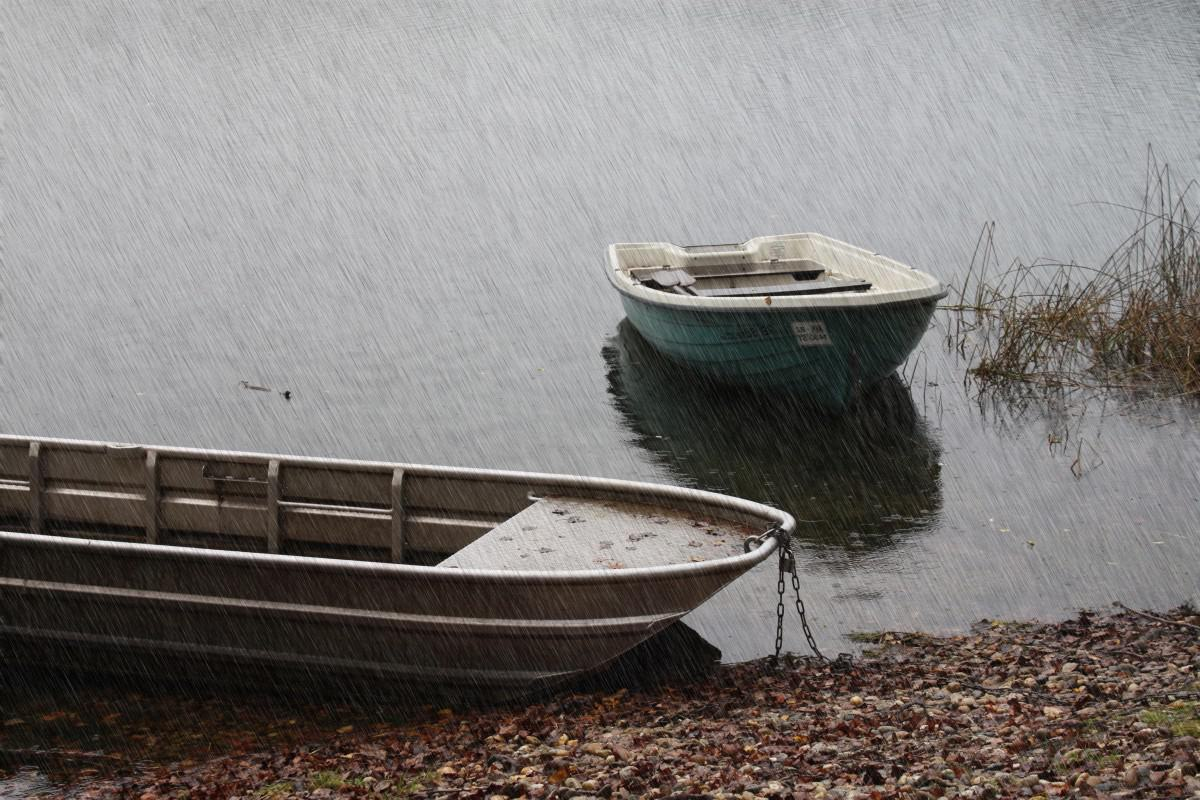Does this image suggest any recreational activities? Yes, the presence of boats implies that the area is used for recreational boating or fishing. However, the inclement weather suggests that such activities would not be occurring at the time the photo was taken. 